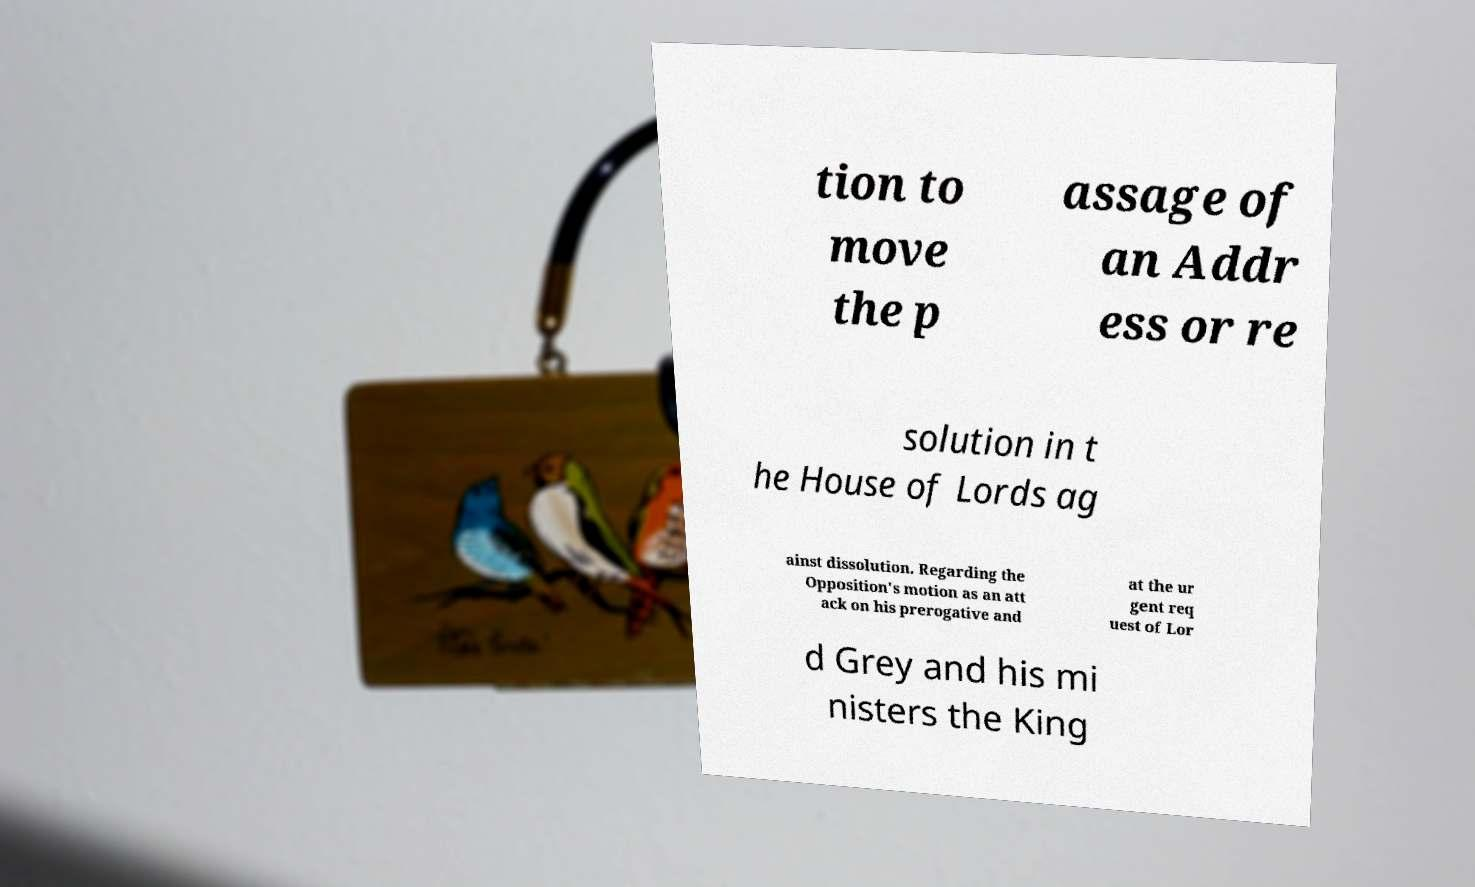Can you read and provide the text displayed in the image?This photo seems to have some interesting text. Can you extract and type it out for me? tion to move the p assage of an Addr ess or re solution in t he House of Lords ag ainst dissolution. Regarding the Opposition's motion as an att ack on his prerogative and at the ur gent req uest of Lor d Grey and his mi nisters the King 